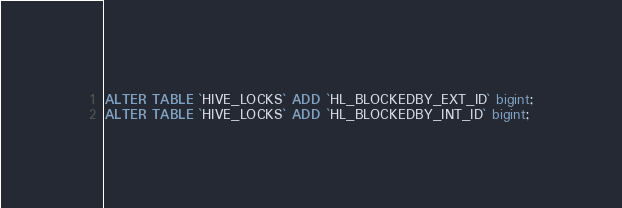Convert code to text. <code><loc_0><loc_0><loc_500><loc_500><_SQL_>ALTER TABLE `HIVE_LOCKS` ADD `HL_BLOCKEDBY_EXT_ID` bigint;
ALTER TABLE `HIVE_LOCKS` ADD `HL_BLOCKEDBY_INT_ID` bigint;
</code> 